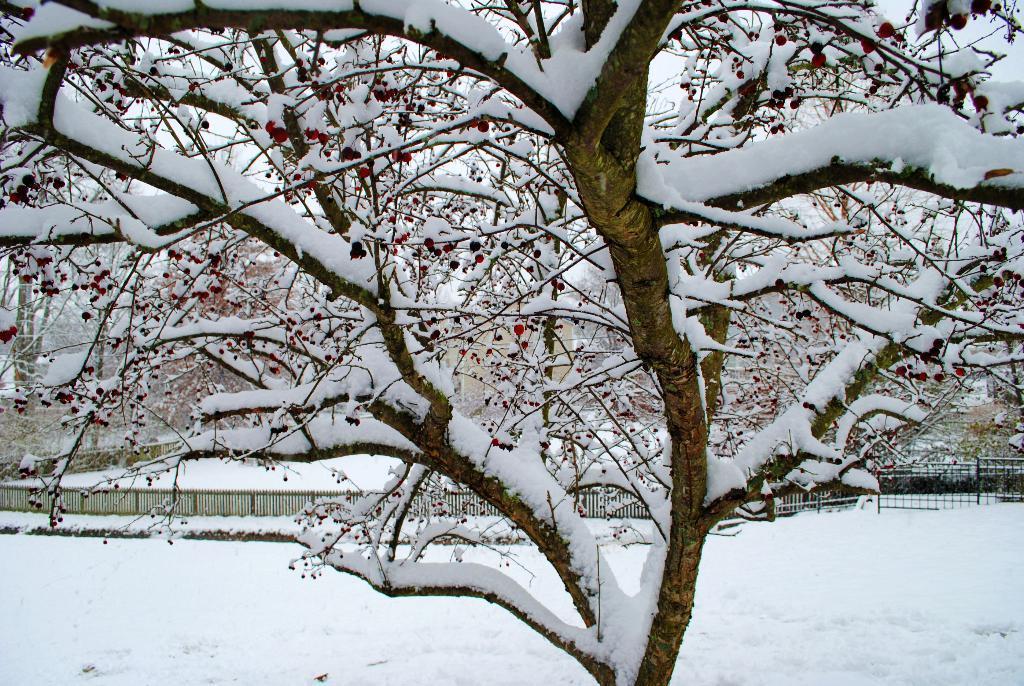Please provide a concise description of this image. In the middle of the image we can see some trees, on the trees we can see snow. Behind the trees we can see fencing. At the bottom of the image we can see snow. 